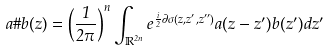<formula> <loc_0><loc_0><loc_500><loc_500>a \# b ( z ) = \left ( \frac { 1 } { 2 \pi } \right ) ^ { n } \int _ { \mathbb { R } ^ { 2 n } } e ^ { \frac { i } { 2 } \partial \sigma ( z , z ^ { \prime } , z ^ { \prime \prime } ) } a ( z - z ^ { \prime } ) b ( z ^ { \prime } ) d z ^ { \prime }</formula> 